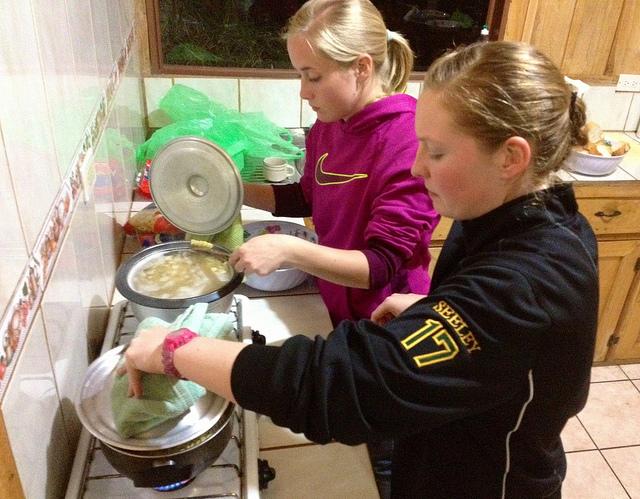What number is on the girls left arm?
Write a very short answer. 17. What color hair do both girls have?
Be succinct. Blonde. What are the girls doing?
Write a very short answer. Cooking. 